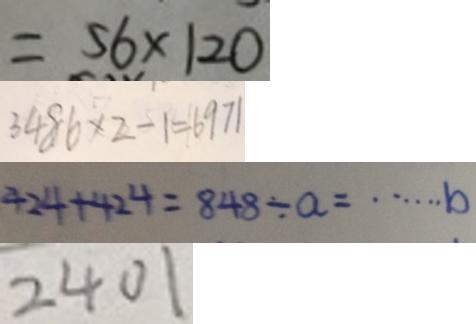Convert formula to latex. <formula><loc_0><loc_0><loc_500><loc_500>= 5 6 \times 1 2 0 
 3 4 8 6 \times 2 - 1 = 6 9 7 1 
 4 2 4 + 4 2 4 = 8 4 8 \div a = \cdots b 
 2 4 0 1</formula> 